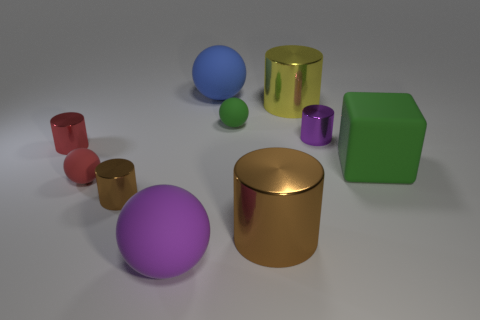Subtract all red cylinders. How many cylinders are left? 4 Subtract all brown spheres. Subtract all purple cylinders. How many spheres are left? 4 Subtract all blocks. How many objects are left? 9 Add 3 small purple metal objects. How many small purple metal objects are left? 4 Add 7 green balls. How many green balls exist? 8 Subtract 0 cyan balls. How many objects are left? 10 Subtract all red spheres. Subtract all tiny rubber things. How many objects are left? 7 